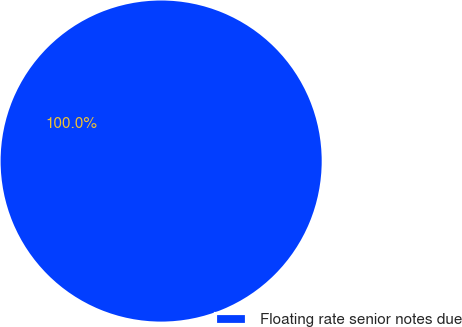Convert chart to OTSL. <chart><loc_0><loc_0><loc_500><loc_500><pie_chart><fcel>Floating rate senior notes due<nl><fcel>100.0%<nl></chart> 